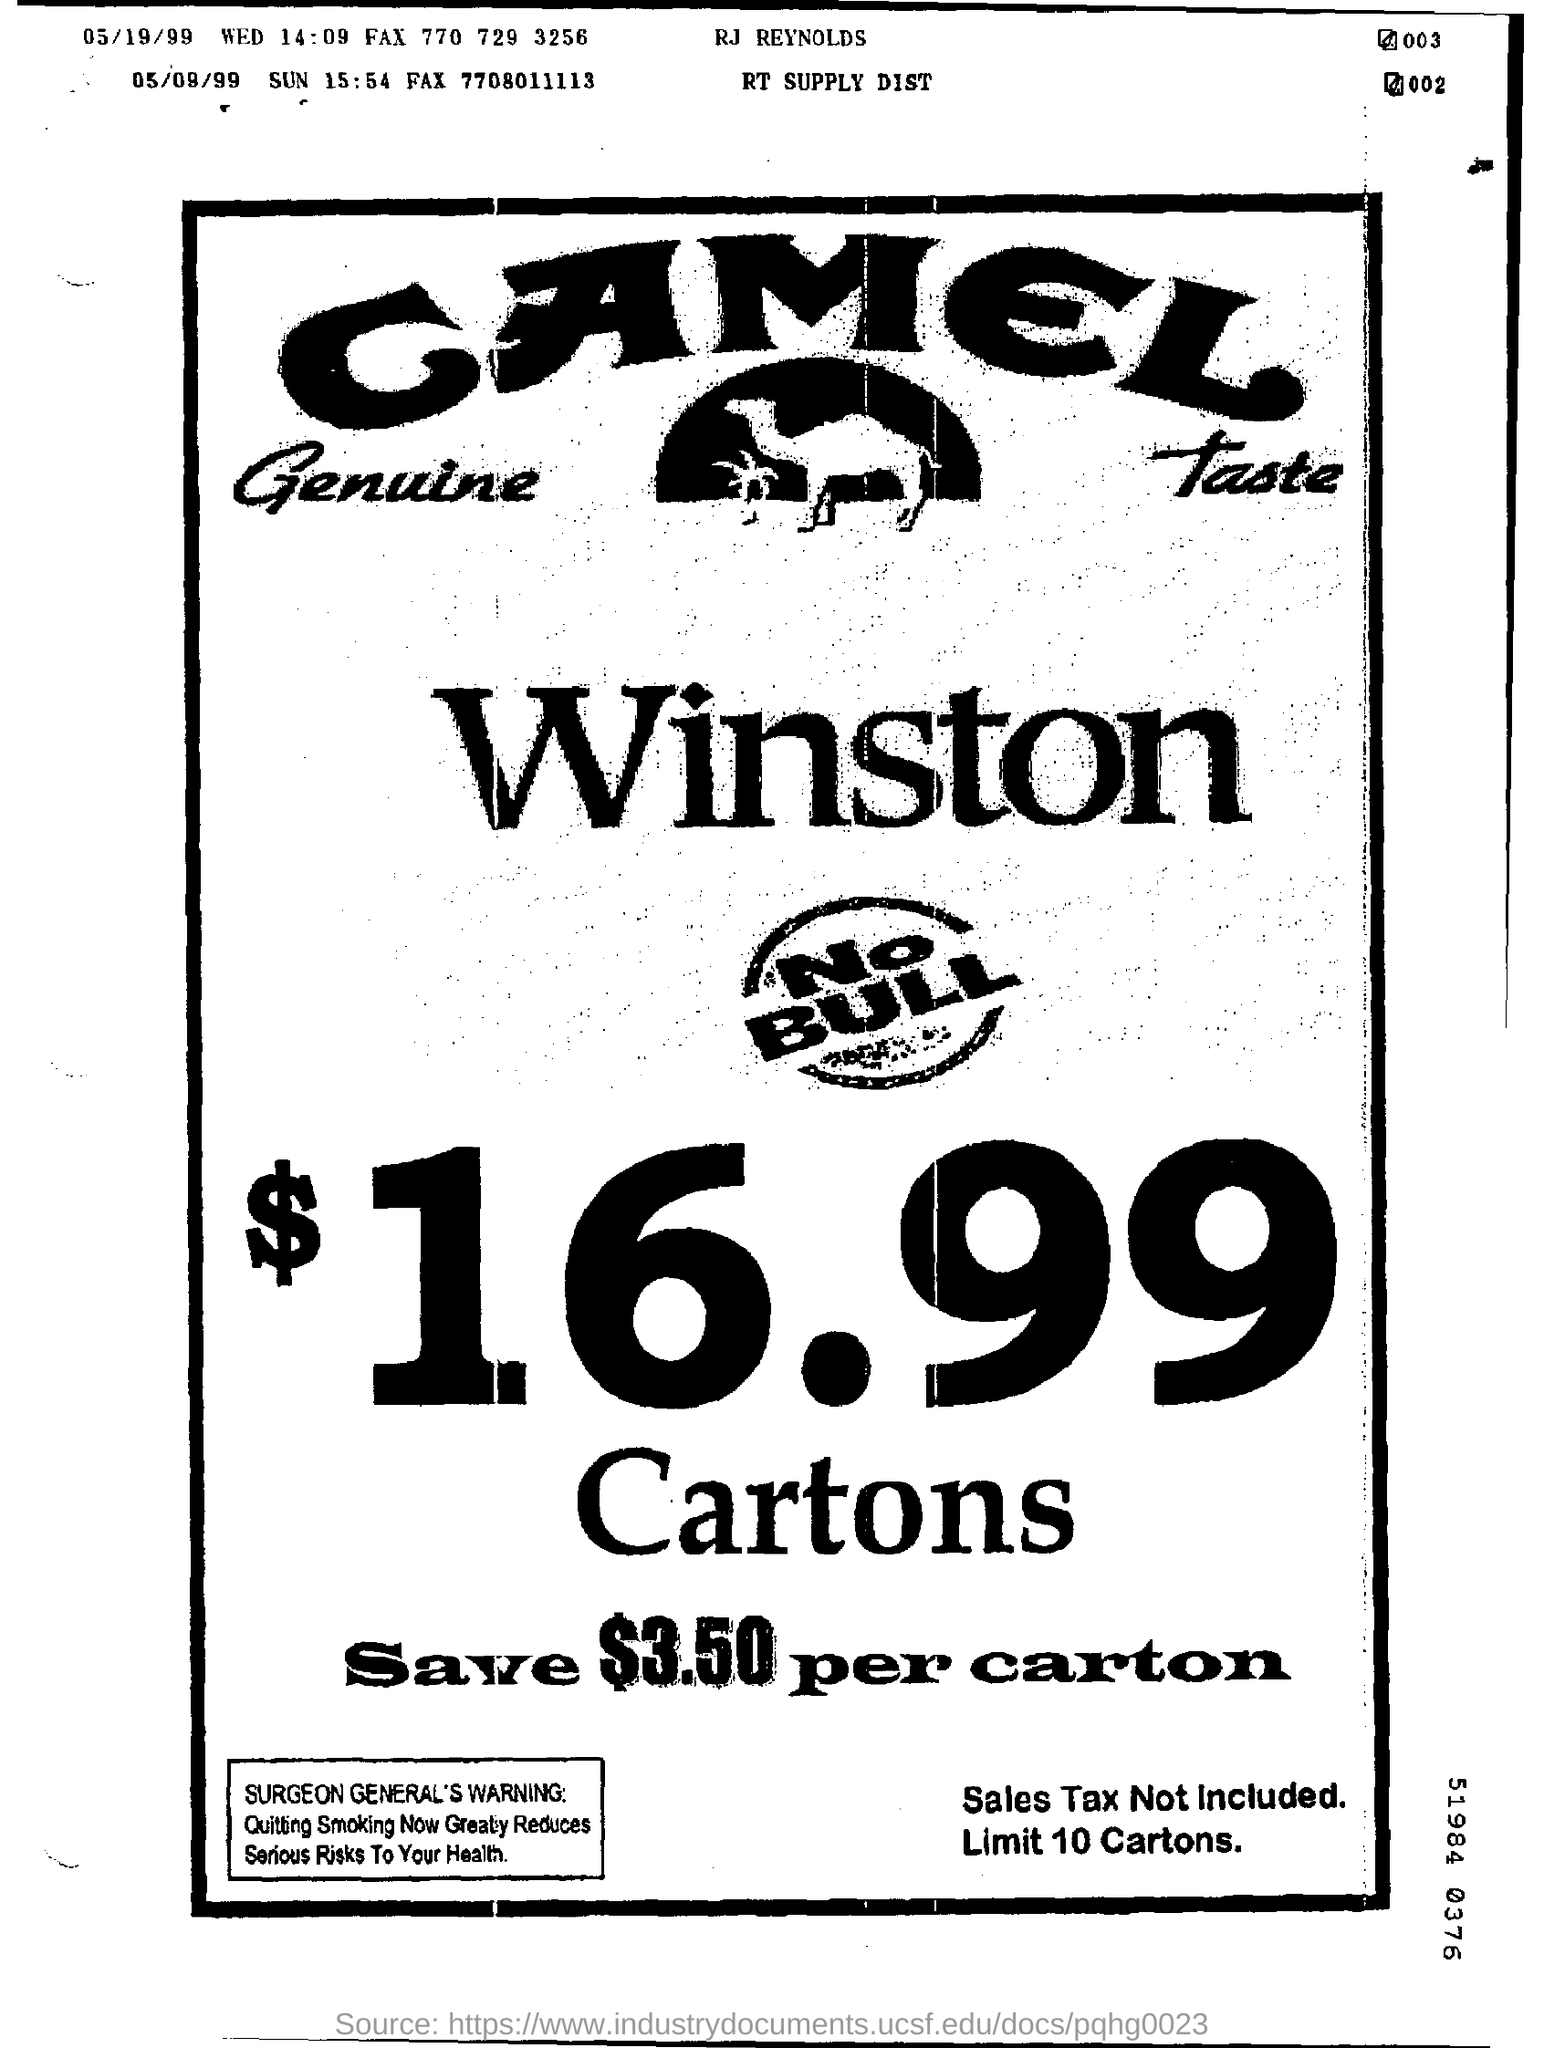What is the date mentioned in the line where RJ Reynolds is printed?
Your response must be concise. 05/19/99. What day was 5/19/99?
Ensure brevity in your answer.  Wed. 